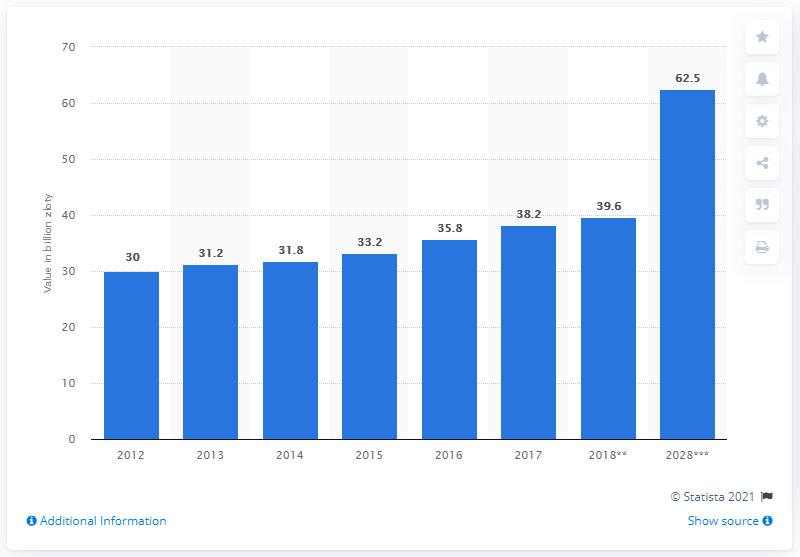Identify some key points in this picture. In 2018, the travel and tourism industry contributed 39.6% to Poland's Gross Domestic Product (GDP). 